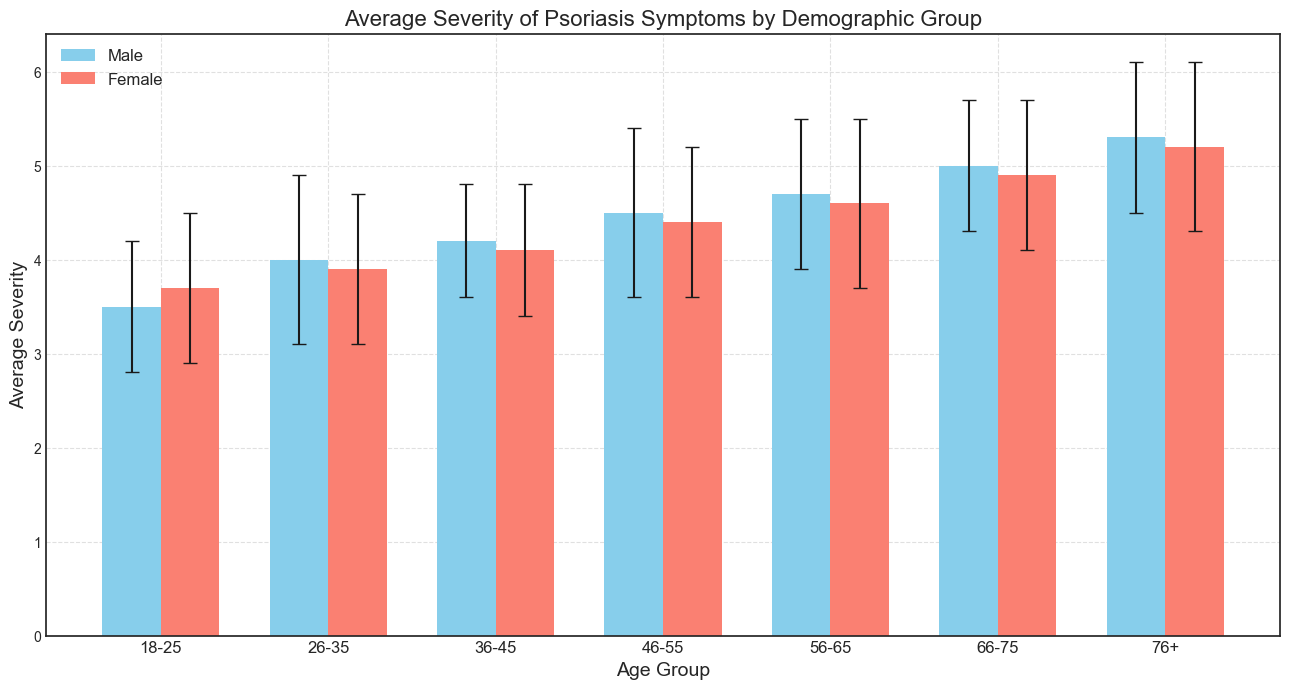Which age group has the highest average severity for males? Looking at the heights of the blue bars representing males, the 76+ age group has the highest bar with an average severity score of 5.3.
Answer: 76+ What is the difference in average severity between males and females in the 56-65 age group? The average severity for males in the 56-65 age group is 4.7, and for females, it is 4.6. So, the difference is 4.7 - 4.6 = 0.1.
Answer: 0.1 Which gender tends to have a higher average severity in the 18-25 age group, and by how much? The average severity for males in the 18-25 age group is 3.5, while for females, it is 3.7. Females have a higher average severity by 3.7 - 3.5 = 0.2.
Answer: Females by 0.2 What is the standard deviation for females in the 46-55 age group? Looking at the error bar for the red bar corresponding to females in the 46-55 age group, the standard deviation is indicated as 0.8.
Answer: 0.8 Between which age groups do males have an average severity difference of 1.0? Comparing the average severity of males between age groups, there is a difference of 1.0 between the 18-25 age group (3.5) and the 36-45 age group (4.5 - 3.5 = 1.0).
Answer: 18-25 and 36-45 What is the average severity for females in the 36-45 age group, and how is it visually represented? The average severity for females in the 36-45 age group is 4.1, visually represented by the height of the red bar for this specific age group.
Answer: 4.1 In which age group do both males and females have almost equal average severity scores? Looking at the bars, the 66-75 age group shows males with an average severity of 5.0 and females with 4.9, which are almost equal.
Answer: 66-75 How much higher is the average severity for males aged 76+ compared to females aged 18-25? The average severity for males aged 76+ is 5.3, while for females aged 18-25, it is 3.7. The difference is 5.3 - 3.7 = 1.6.
Answer: 1.6 What is the combined average severity of males and females in the 26-35 age group? The average severity for males in the 26-35 age group is 4.0, and for females it is 3.9. The combined average is (4.0 + 3.9) / 2 = 3.95.
Answer: 3.95 